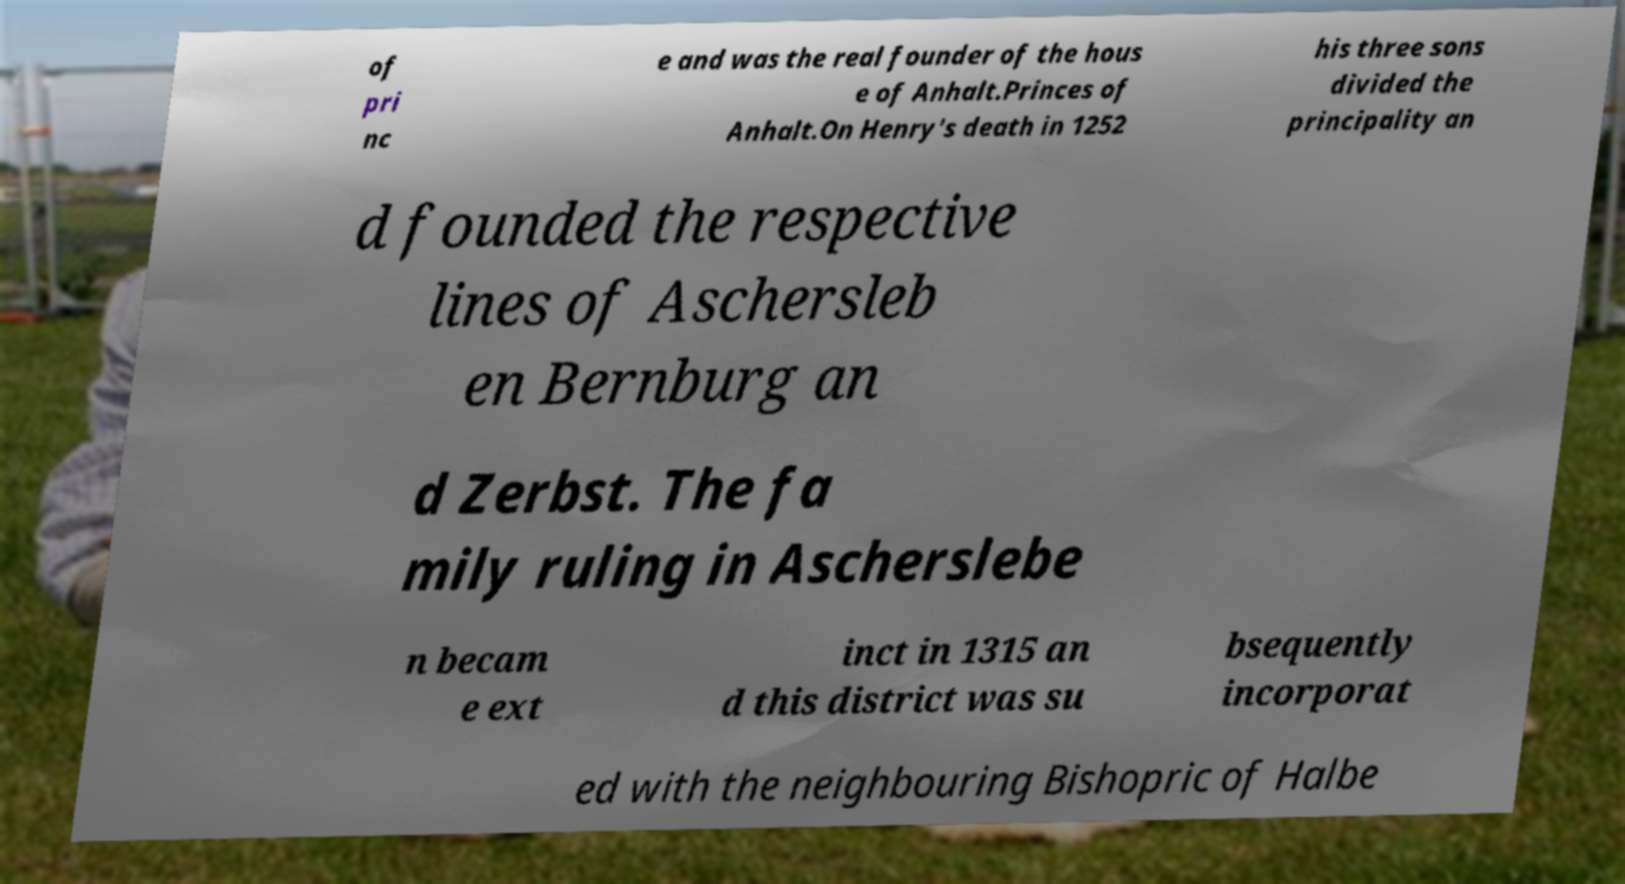Can you read and provide the text displayed in the image?This photo seems to have some interesting text. Can you extract and type it out for me? of pri nc e and was the real founder of the hous e of Anhalt.Princes of Anhalt.On Henry's death in 1252 his three sons divided the principality an d founded the respective lines of Aschersleb en Bernburg an d Zerbst. The fa mily ruling in Ascherslebe n becam e ext inct in 1315 an d this district was su bsequently incorporat ed with the neighbouring Bishopric of Halbe 